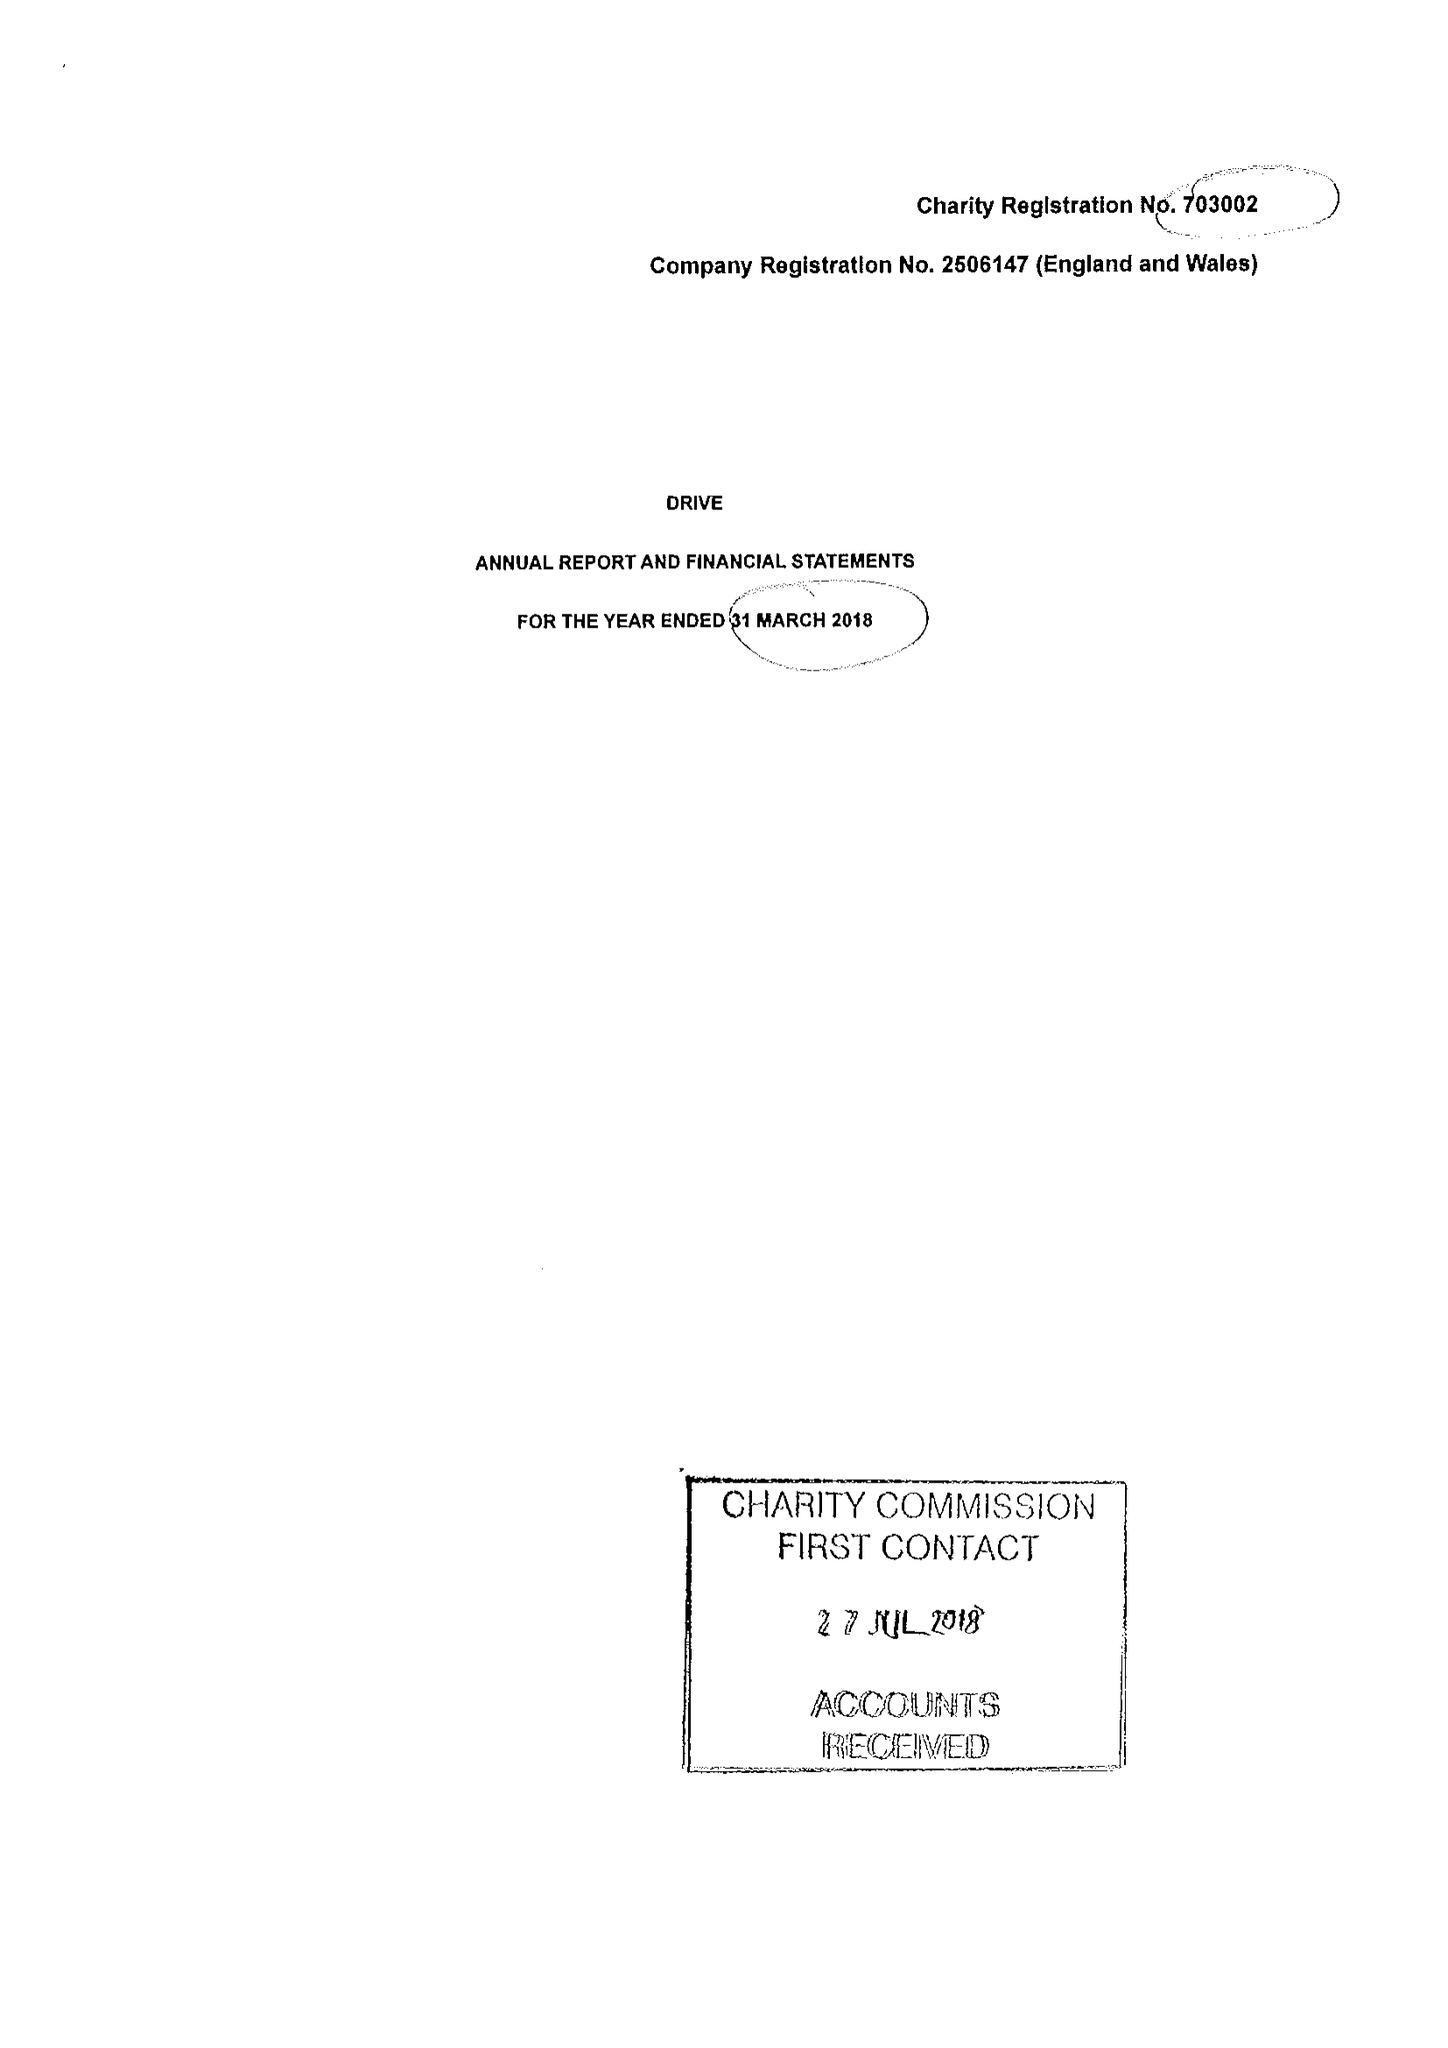What is the value for the charity_name?
Answer the question using a single word or phrase. Drive 